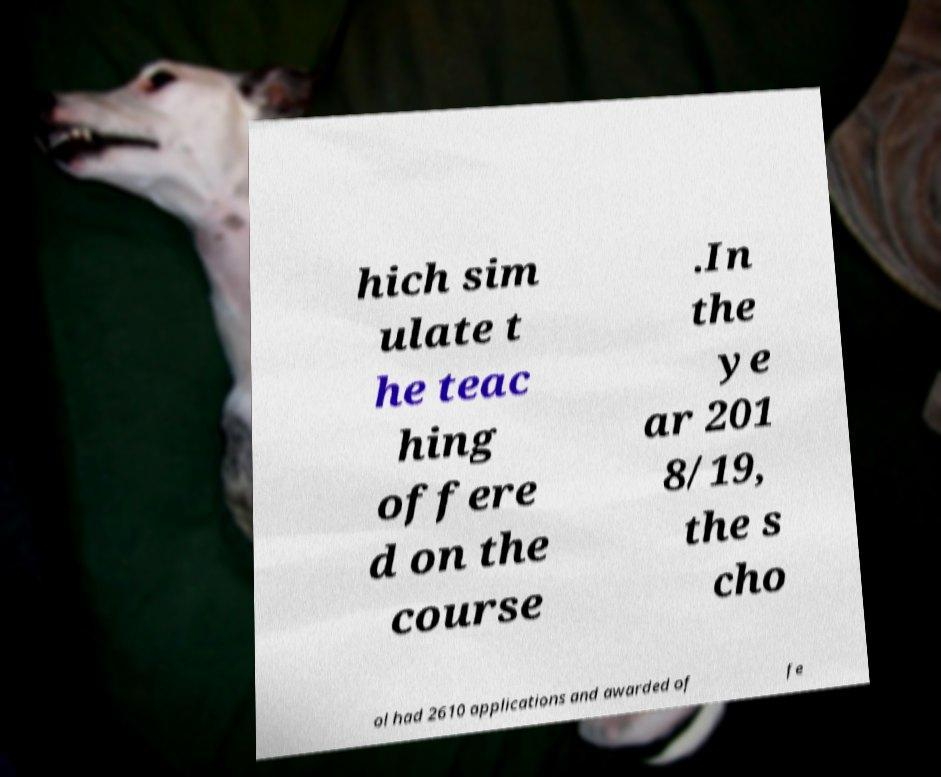Can you read and provide the text displayed in the image?This photo seems to have some interesting text. Can you extract and type it out for me? hich sim ulate t he teac hing offere d on the course .In the ye ar 201 8/19, the s cho ol had 2610 applications and awarded of fe 